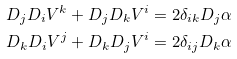Convert formula to latex. <formula><loc_0><loc_0><loc_500><loc_500>D _ { j } D _ { i } V ^ { k } + D _ { j } D _ { k } V ^ { i } = 2 \delta _ { i k } D _ { j } \alpha \\ D _ { k } D _ { i } V ^ { j } + D _ { k } D _ { j } V ^ { i } = 2 \delta _ { i j } D _ { k } \alpha</formula> 